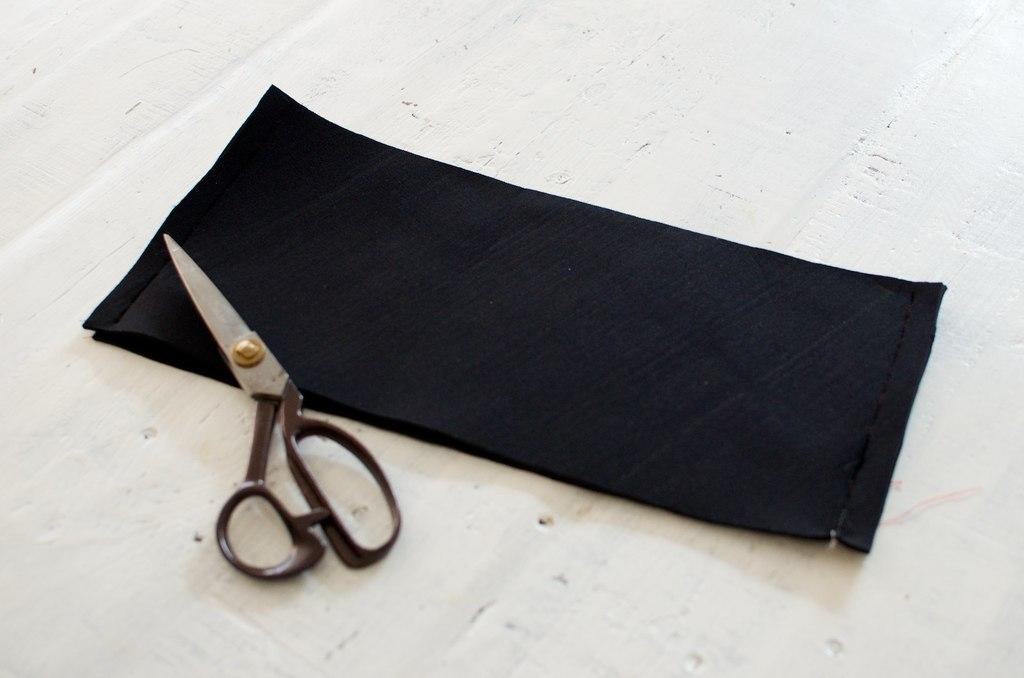What color is the cloth that is visible in the image? The cloth in the image is black. Where is the black cloth located in the image? The black cloth is in the center of the image. What tool is present in the image? There is a pair of scissors in the image. On what is the pair of scissors placed? The scissors are placed on top of an object. What type of bird is perched on the crown in the image? There is no crown or bird present in the image. How much grain is visible in the image? There is no grain present in the image. 